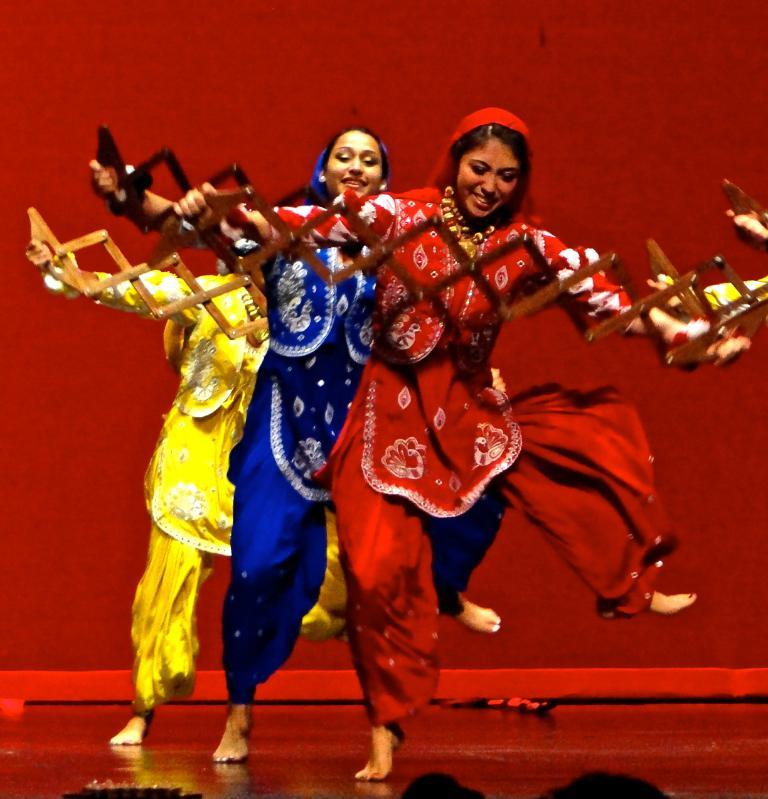Who is present in the image? There are women in the image. What are the women wearing? The women are wearing different color dresses. What are the women doing in the image? The women are dancing. What appliance is being used by the women to reason in the image? There is no appliance present in the image, and the women are not shown reasoning. 